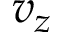<formula> <loc_0><loc_0><loc_500><loc_500>v _ { z }</formula> 